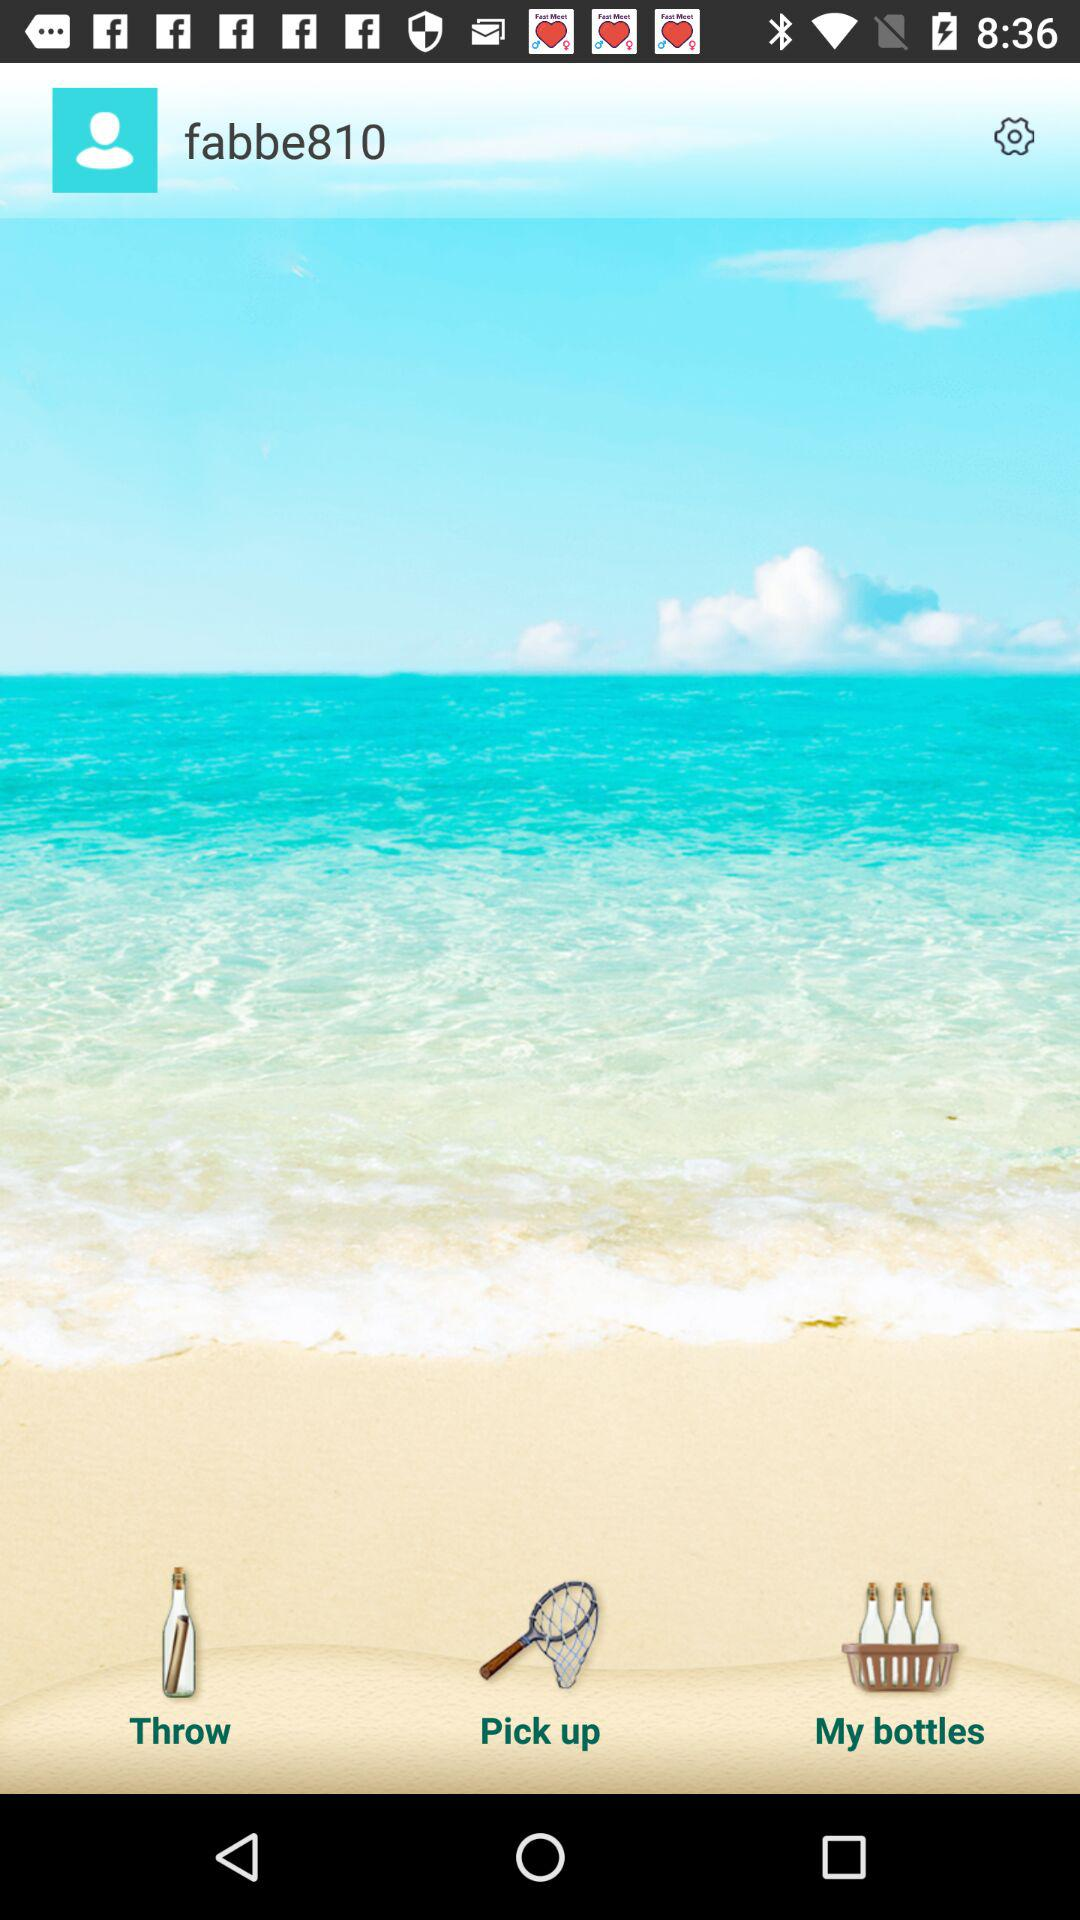How many bottles have been thrown?
When the provided information is insufficient, respond with <no answer>. <no answer> 